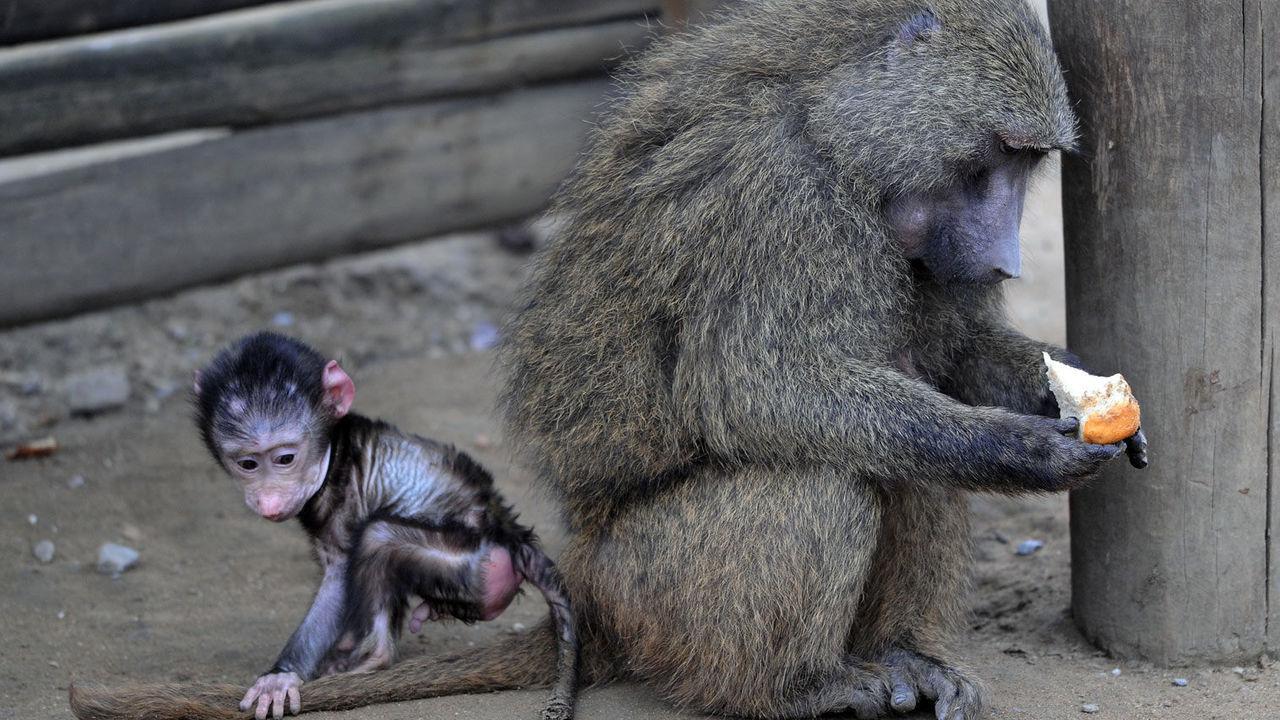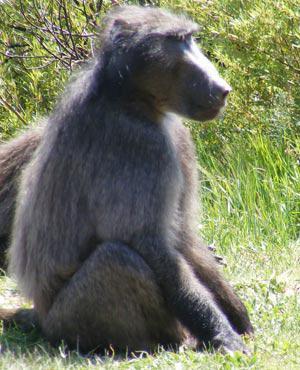The first image is the image on the left, the second image is the image on the right. Examine the images to the left and right. Is the description "In one image there is an adult monkey holding onto food with a young monkey nearby." accurate? Answer yes or no. Yes. The first image is the image on the left, the second image is the image on the right. Examine the images to the left and right. Is the description "One image shows the face of a fang-baring baboon in profile, and the other image includes a baby baboon." accurate? Answer yes or no. No. 